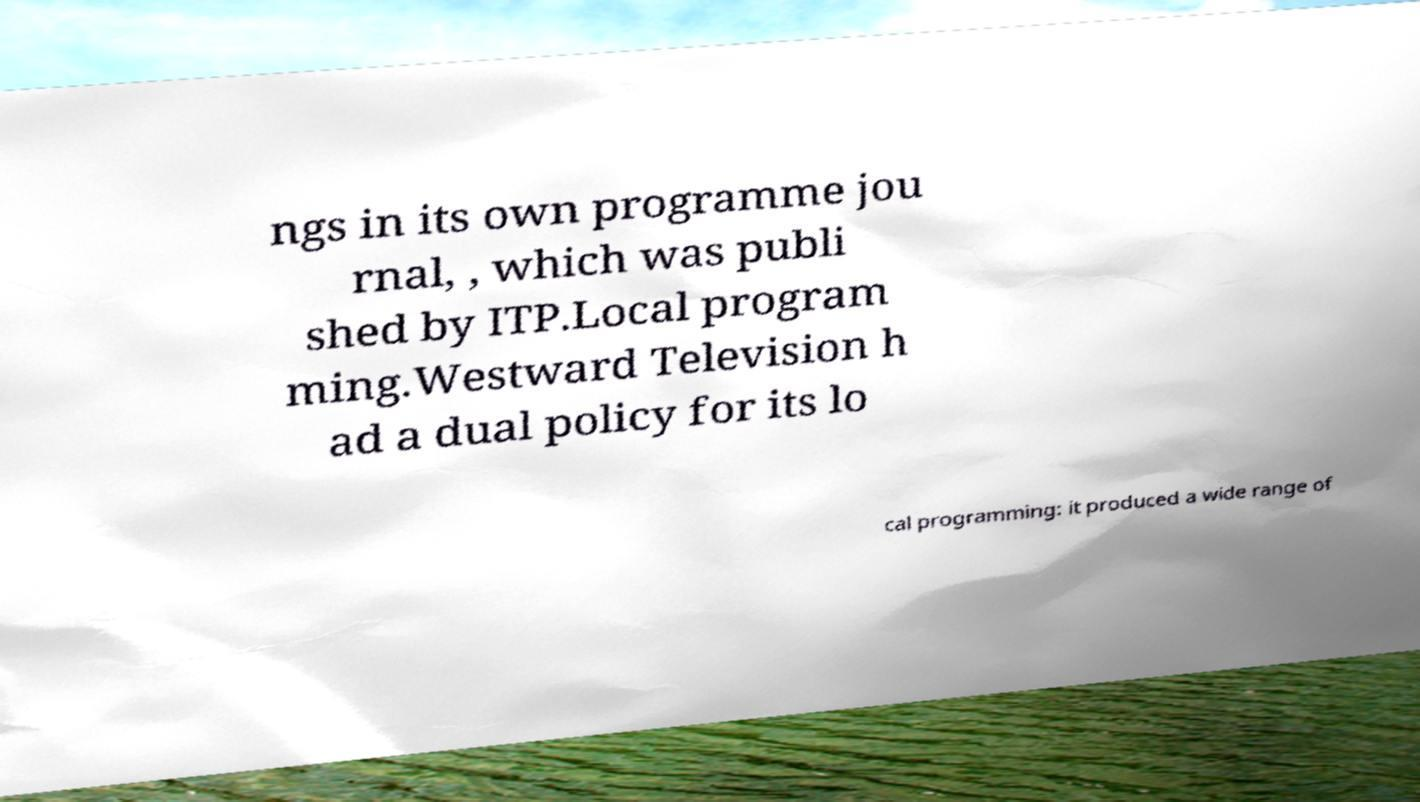Please read and relay the text visible in this image. What does it say? ngs in its own programme jou rnal, , which was publi shed by ITP.Local program ming.Westward Television h ad a dual policy for its lo cal programming: it produced a wide range of 